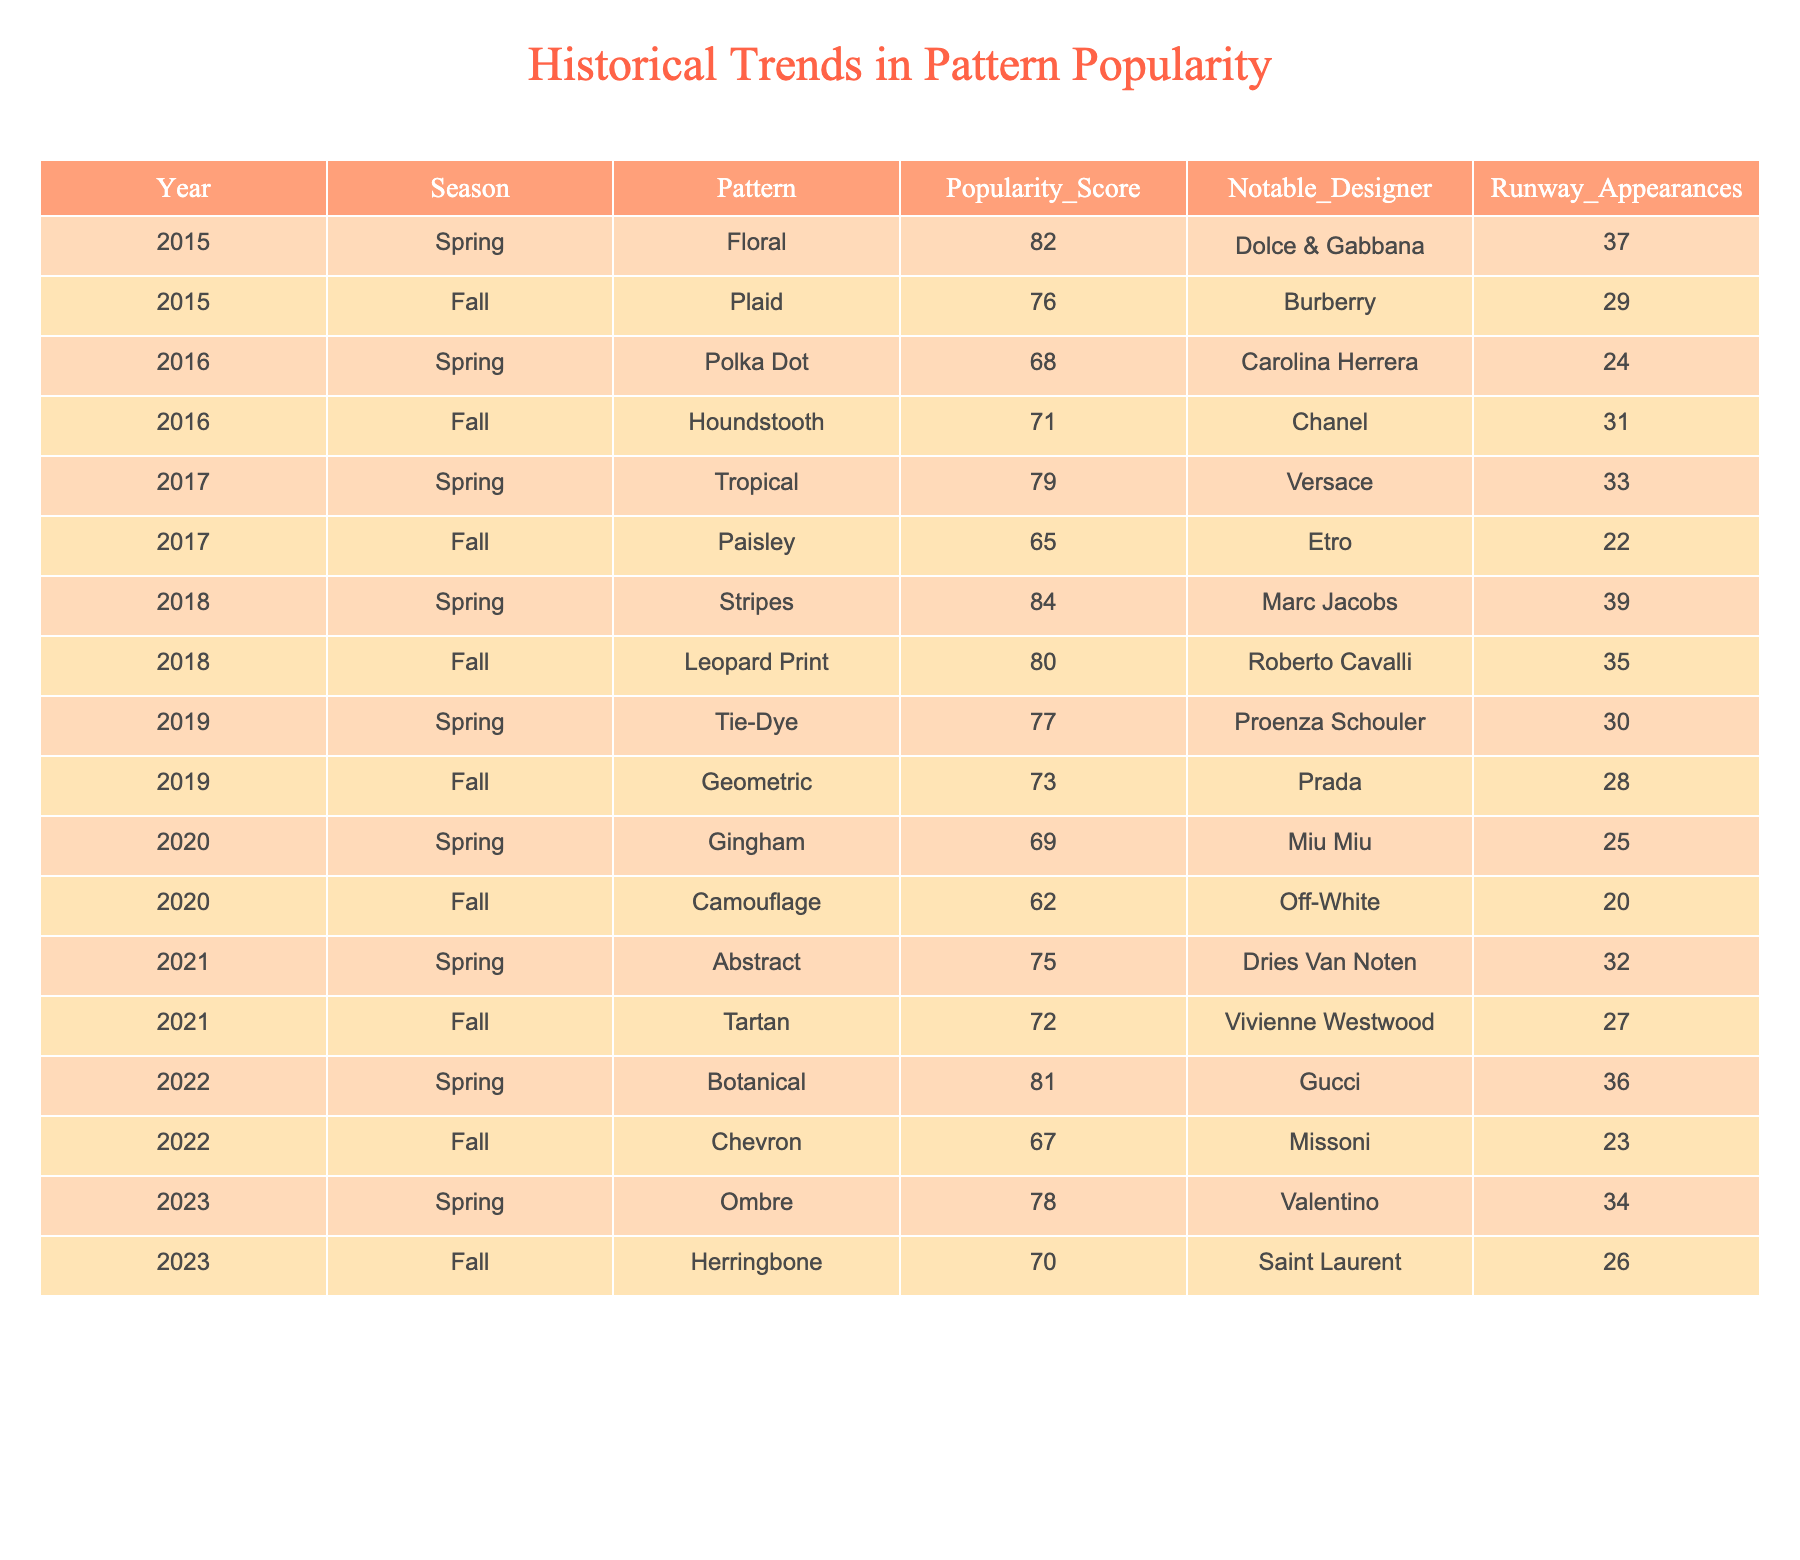What was the most popular pattern in Spring 2018? The table indicates that the most popular pattern in Spring 2018 is "Stripes" with a popularity score of 84, the highest among all Spring seasons listed in the table.
Answer: Stripes Which designer showcased the "Polka Dot" pattern in Spring 2016? The table shows that Carolina Herrera is the notable designer who showcased the "Polka Dot" pattern in Spring 2016.
Answer: Carolina Herrera In which season was the "Houndstooth" pattern the most popular? The table lists "Houndstooth" in the Fall season of 2016 with a popularity score of 71, making it the only recorded instance in that season.
Answer: Fall 2016 What is the average popularity score for patterns from the Spring season? By adding the Spring scores: 82 (Floral) + 68 (Polka Dot) + 79 (Tropical) + 84 (Stripes) + 77 (Tie-Dye) + 69 (Gingham) + 75 (Abstract) + 81 (Botanical) + 78 (Ombre) =  59/9 = 78.
Answer: 78 Did "Camouflage" pattern appear more frequently than "Paisley" on the runway? "Camouflage" had 20 runway appearances in Fall 2020, while "Paisley" had 22 in Fall 2017, indicating that "Camouflage" appeared less frequently.
Answer: No What was the highest recorded popularity score for Fall patterns? The table reveals that the "Leopard Print" pattern had the highest popularity score of 80 in Fall 2018, compared to other Fall patterns listed.
Answer: 80 Which Spring season had a designer other than Gucci that scored above 80 in popularity? In Spring 2018, "Stripes" scored 84 with Marc Jacobs as the designer, which was above 80.
Answer: Spring 2018 How many runway appearances did the "Chevron" pattern have compared to the "Geometric" pattern? "Chevron" had 23 appearances in Fall 2022 and "Geometric" had 28 appearances in Fall 2019, meaning "Geometric" appeared 5 times more than "Chevron."
Answer: Geometric had more appearances What is the trend in popularity scores for Spring patterns from 2015 to 2023? The Spring scores are: 82, 68, 79, 84, 77, 69, 75, 81, 78. The trend is generally fluctuating but mostly within the 68-84 range with a slight decrease in 2020.
Answer: Fluctuating Which two patterns had the lowest popularity scores in the dataset? The patterns with the lowest scores are "Camouflage" at 62 in Fall 2020 and "Paisley" at 65 in Fall 2017, making them the two least popular patterns.
Answer: Camouflage and Paisley 